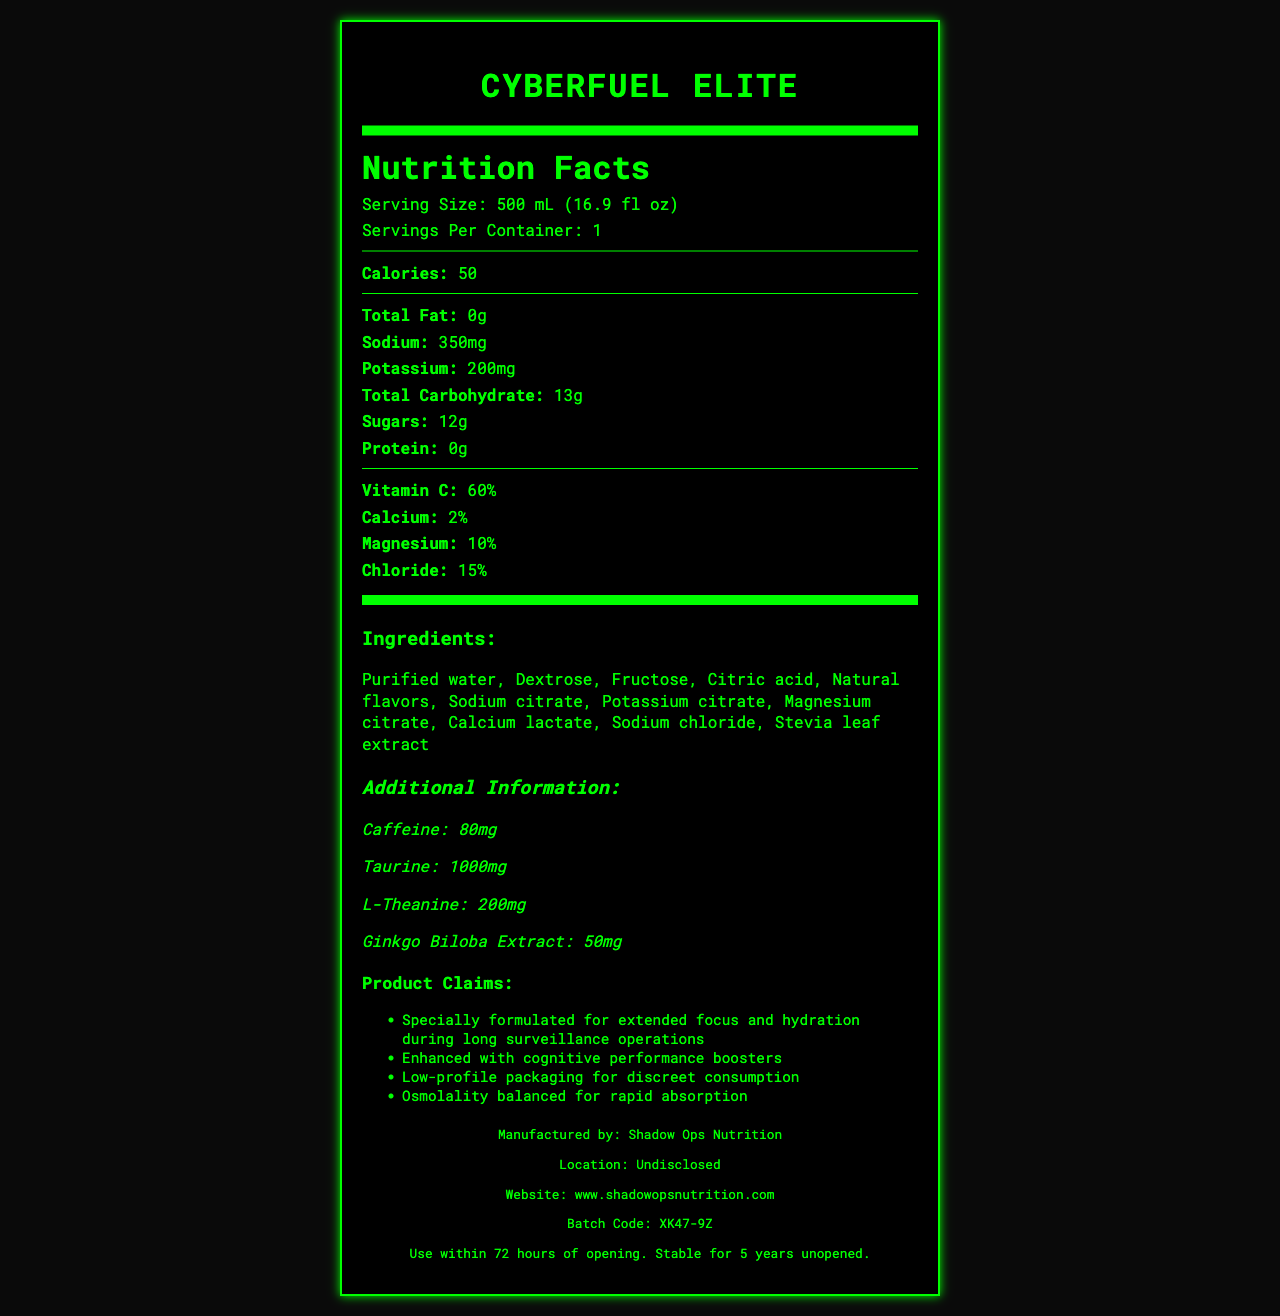what is the serving size of CyberFuel Elite? The document lists the serving size as "500 mL (16.9 fl oz)" under the Nutrition Facts section.
Answer: 500 mL (16.9 fl oz) how much potassium is in one serving? The Nutrition Facts section indicates that one serving contains 200mg of potassium.
Answer: 200mg how much protein does CyberFuel Elite contain? The Nutrition Facts section clearly states that the protein content is 0g per serving.
Answer: 0g what is the maximum shelf life of this product if unopened? The expiration information in the manufacturer section states that the product is stable for 5 years if unopened.
Answer: 5 years how many calories are in one serving? The Nutrition Facts section lists 50 calories per serving.
Answer: 50 calories which of the following ingredients is not in CyberFuel Elite? A. Sodium citrate B. Potassium citrate C. Saccharin D. Stevia leaf extract Saccharin is not listed in the ingredients section of CyberFuel Elite, while sodium citrate, potassium citrate, and stevia leaf extract are listed.
Answer: C. Saccharin what percentage of Vitamin C does one serving provide? A. 20% B. 45% C. 60% D. 80% The Nutrition Facts section indicates that one serving provides 60% of the daily value for Vitamin C.
Answer: C. 60% is this product caffeine-free? The additional information section lists caffeine content as 80mg.
Answer: No describe the main purpose of CyberFuel Elite. The product claims section highlights that CyberFuel Elite is specifically formulated for extended focus and hydration during long surveillance operations and it is enhanced with cognitive performance boosters.
Answer: CyberFuel Elite is designed for extended focus and hydration during long surveillance operations, and it includes cognitive performance boosters. what is the URL for the manufacturer's website? The manufacturer information section provides the website as www.shadowopsnutrition.com.
Answer: www.shadowopsnutrition.com can we determine the production date of this product from the document? The document does not provide any details or formats for determining the production date, only a batch code and expiration information are given.
Answer: Not enough information 